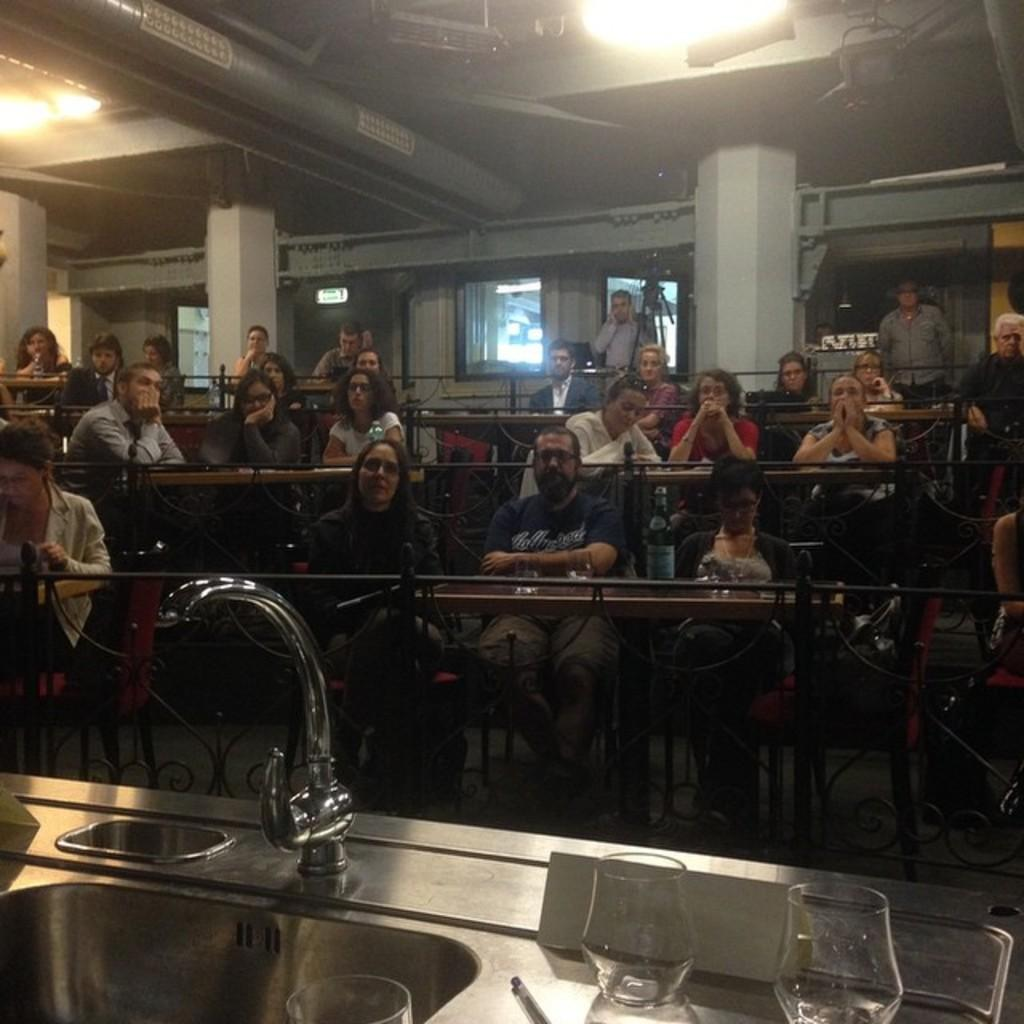How many people are in the image? There is a group of persons in the image. What are the persons in the image doing? The persons are sitting on chairs. What can be seen in the foreground of the image? There is a tap and glasses in the foreground of the image. How many windows can be seen in the image? There is no window visible in the image. What type of foot is present in the image? There is no foot present in the image. 